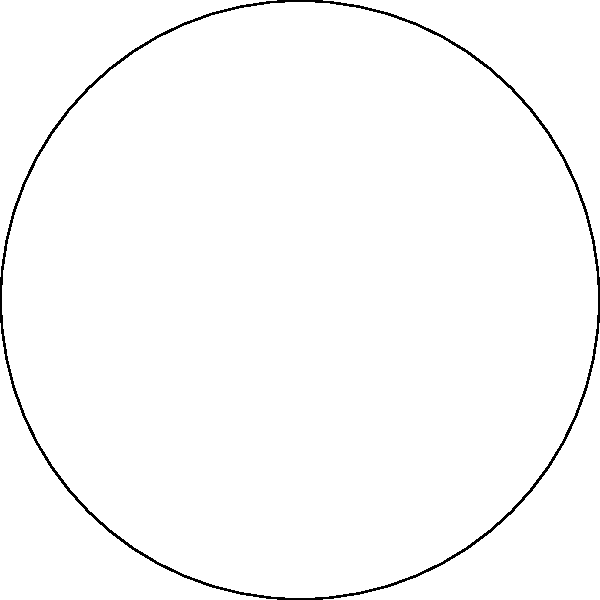As a field officer advising on efficient irrigation, you're designing a circular sprinkler system for a crop field. The system has a radius of 30 meters, and you want to place sprinklers along the circumference for optimal coverage. If each sprinkler covers a 60° arc, how many sprinklers should be placed around the circle to ensure complete coverage without overlap? To solve this problem, we need to follow these steps:

1. Understand the given information:
   - The circular field has a radius of 30 meters
   - Each sprinkler covers a 60° arc

2. Recall that a full circle contains 360°

3. Calculate the number of sprinklers needed:
   - Number of sprinklers = Total degrees in a circle / Degrees covered by each sprinkler
   - Number of sprinklers = 360° / 60°
   - Number of sprinklers = 6

4. Verify the solution:
   - 6 sprinklers * 60° per sprinkler = 360°
   - This confirms complete coverage without overlap

5. Consider the practical application:
   - The sprinklers should be evenly spaced around the circumference
   - The angle between each sprinkler from the center will be 60°
   - This arrangement ensures uniform coverage across the entire circular field
Answer: 6 sprinklers 